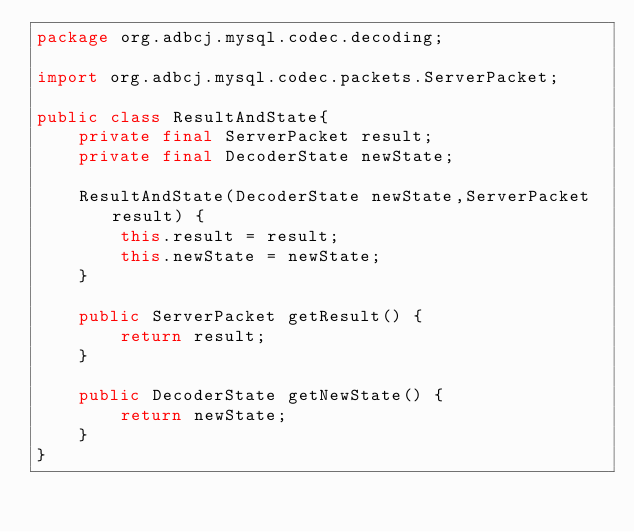Convert code to text. <code><loc_0><loc_0><loc_500><loc_500><_Java_>package org.adbcj.mysql.codec.decoding;

import org.adbcj.mysql.codec.packets.ServerPacket;

public class ResultAndState{
    private final ServerPacket result;
    private final DecoderState newState;

    ResultAndState(DecoderState newState,ServerPacket result) {
        this.result = result;
        this.newState = newState;
    }

    public ServerPacket getResult() {
        return result;
    }

    public DecoderState getNewState() {
        return newState;
    }
}
</code> 